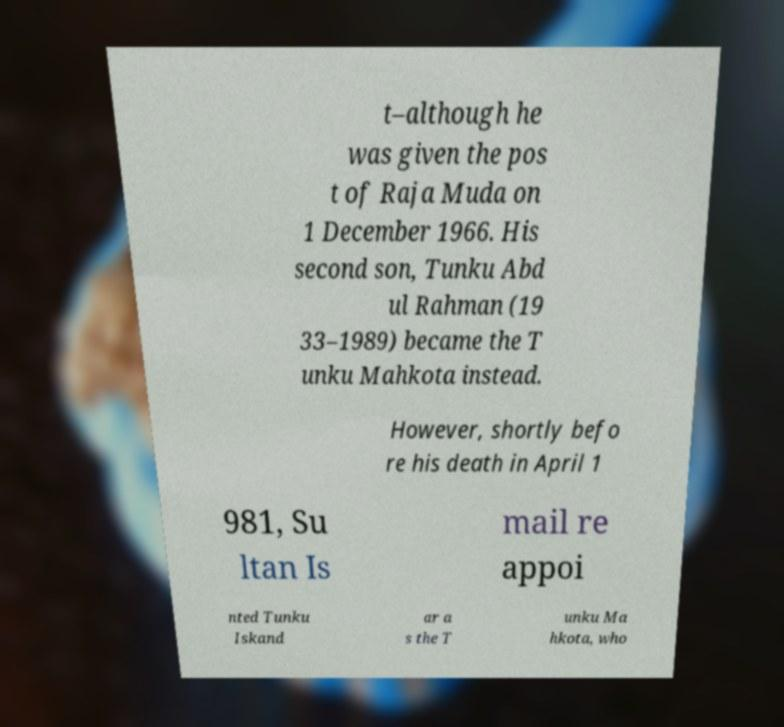Can you accurately transcribe the text from the provided image for me? t–although he was given the pos t of Raja Muda on 1 December 1966. His second son, Tunku Abd ul Rahman (19 33–1989) became the T unku Mahkota instead. However, shortly befo re his death in April 1 981, Su ltan Is mail re appoi nted Tunku Iskand ar a s the T unku Ma hkota, who 